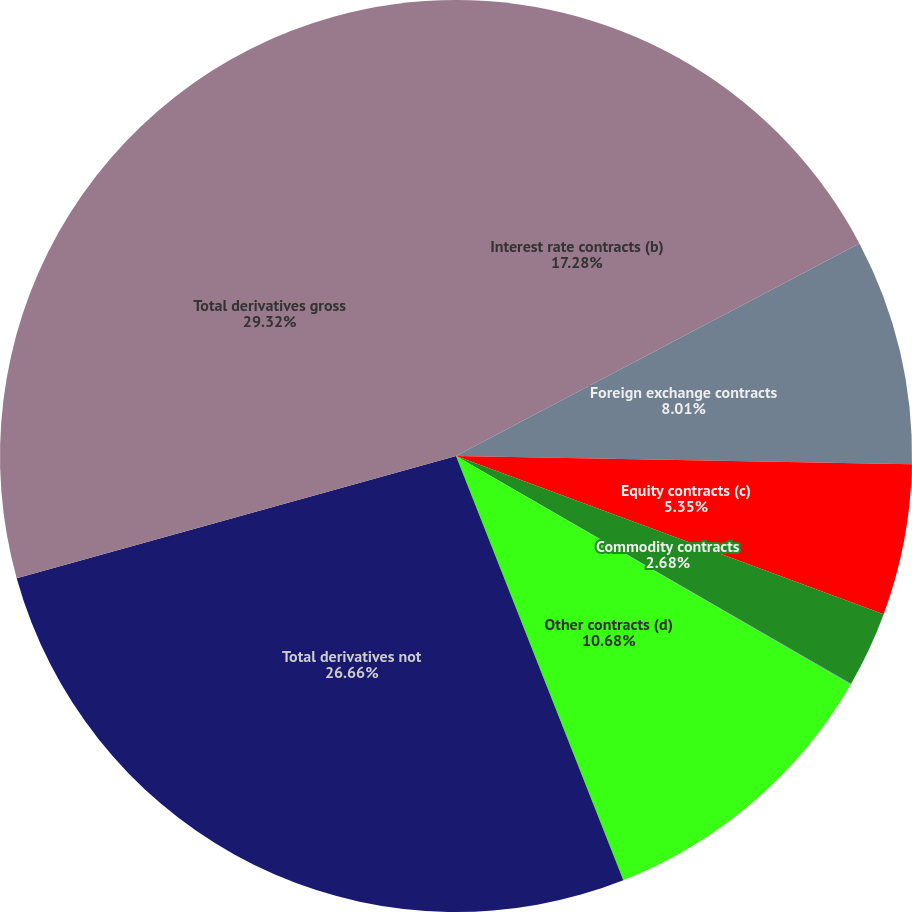<chart> <loc_0><loc_0><loc_500><loc_500><pie_chart><fcel>Interest rate contracts (b)<fcel>Foreign exchange contracts<fcel>Equity contracts (c)<fcel>Commodity contracts<fcel>Credit contracts<fcel>Other contracts (d)<fcel>Total derivatives not<fcel>Total derivatives gross<nl><fcel>17.28%<fcel>8.01%<fcel>5.35%<fcel>2.68%<fcel>0.02%<fcel>10.68%<fcel>26.66%<fcel>29.32%<nl></chart> 